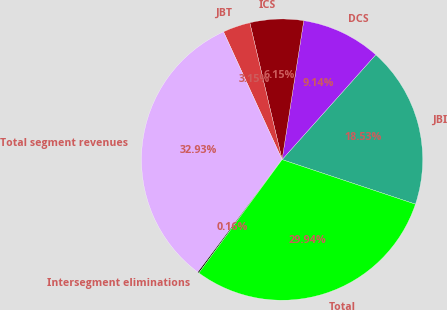Convert chart. <chart><loc_0><loc_0><loc_500><loc_500><pie_chart><fcel>JBI<fcel>DCS<fcel>ICS<fcel>JBT<fcel>Total segment revenues<fcel>Intersegment eliminations<fcel>Total<nl><fcel>18.53%<fcel>9.14%<fcel>6.15%<fcel>3.15%<fcel>32.93%<fcel>0.16%<fcel>29.94%<nl></chart> 